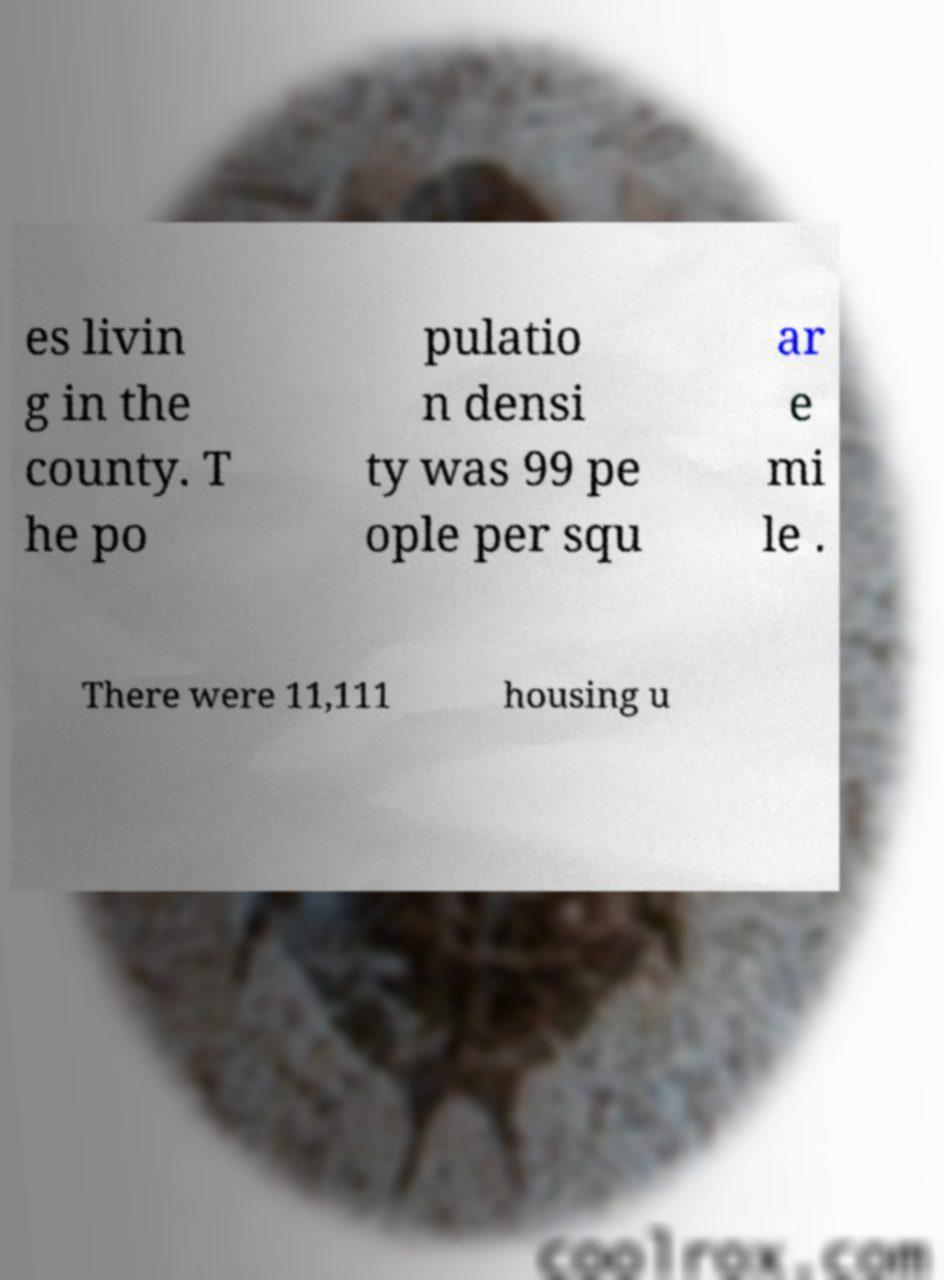What messages or text are displayed in this image? I need them in a readable, typed format. es livin g in the county. T he po pulatio n densi ty was 99 pe ople per squ ar e mi le . There were 11,111 housing u 